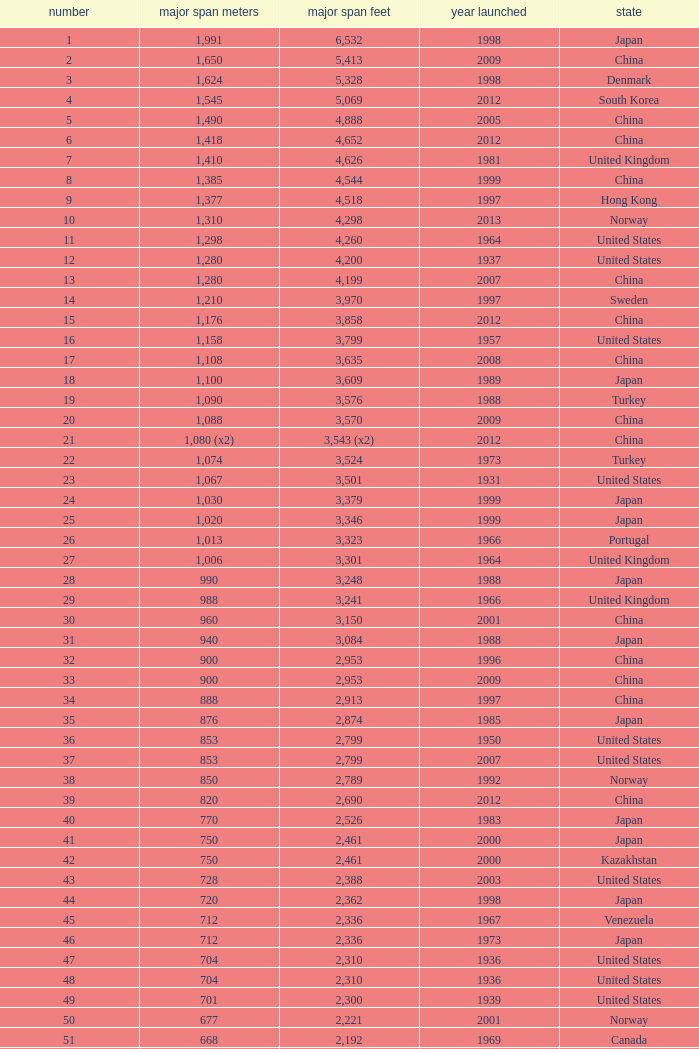What is the oldest year with a main span feet of 1,640 in South Korea? 2002.0. 